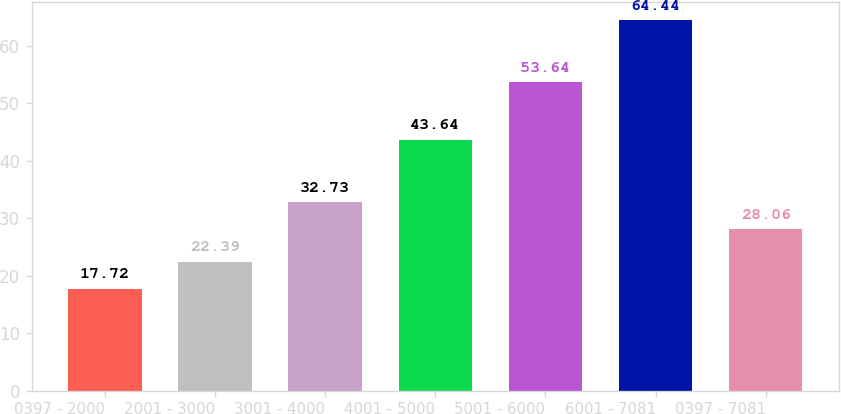Convert chart. <chart><loc_0><loc_0><loc_500><loc_500><bar_chart><fcel>0397 - 2000<fcel>2001 - 3000<fcel>3001 - 4000<fcel>4001 - 5000<fcel>5001 - 6000<fcel>6001 - 7081<fcel>0397 - 7081<nl><fcel>17.72<fcel>22.39<fcel>32.73<fcel>43.64<fcel>53.64<fcel>64.44<fcel>28.06<nl></chart> 